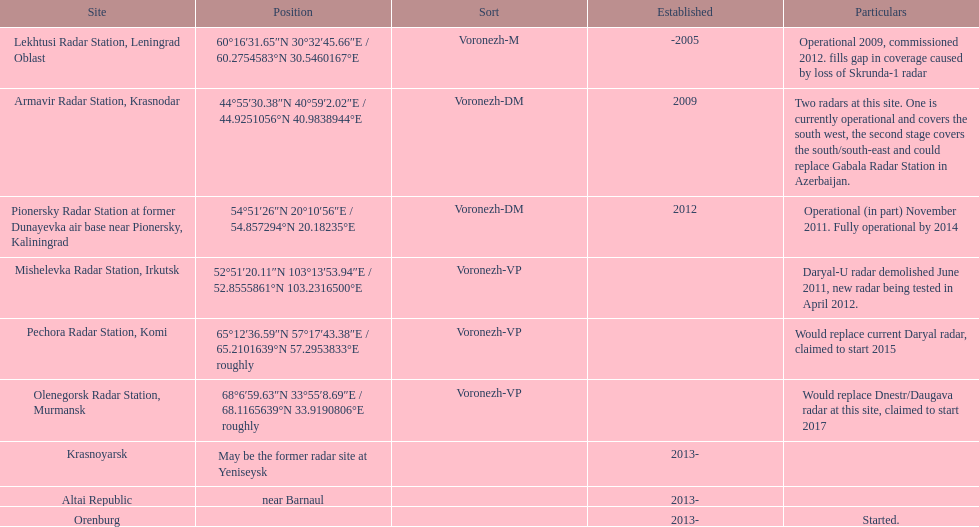What is the only radar that will start in 2015? Pechora Radar Station, Komi. 